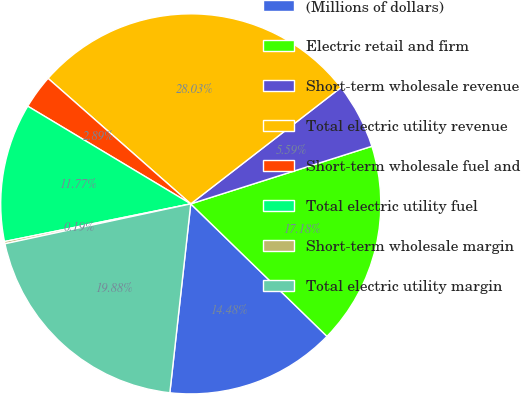Convert chart. <chart><loc_0><loc_0><loc_500><loc_500><pie_chart><fcel>(Millions of dollars)<fcel>Electric retail and firm<fcel>Short-term wholesale revenue<fcel>Total electric utility revenue<fcel>Short-term wholesale fuel and<fcel>Total electric utility fuel<fcel>Short-term wholesale margin<fcel>Total electric utility margin<nl><fcel>14.48%<fcel>17.18%<fcel>5.59%<fcel>28.03%<fcel>2.89%<fcel>11.77%<fcel>0.19%<fcel>19.88%<nl></chart> 